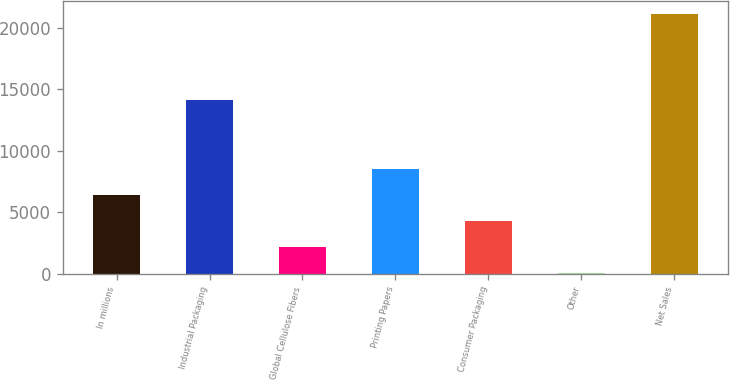<chart> <loc_0><loc_0><loc_500><loc_500><bar_chart><fcel>In millions<fcel>Industrial Packaging<fcel>Global Cellulose Fibers<fcel>Printing Papers<fcel>Consumer Packaging<fcel>Other<fcel>Net Sales<nl><fcel>6385.3<fcel>14095<fcel>2187.1<fcel>8484.4<fcel>4286.2<fcel>88<fcel>21079<nl></chart> 